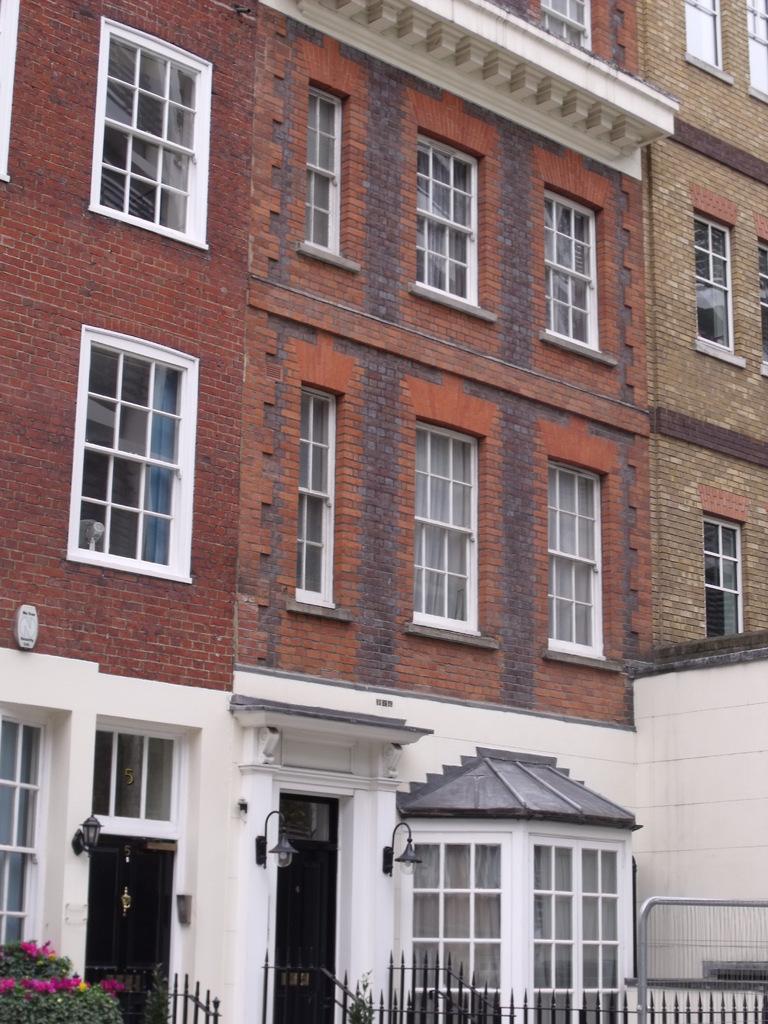Please provide a concise description of this image. In this picture, we can see buildings with windows and in front of the building there is a fence and plants. 